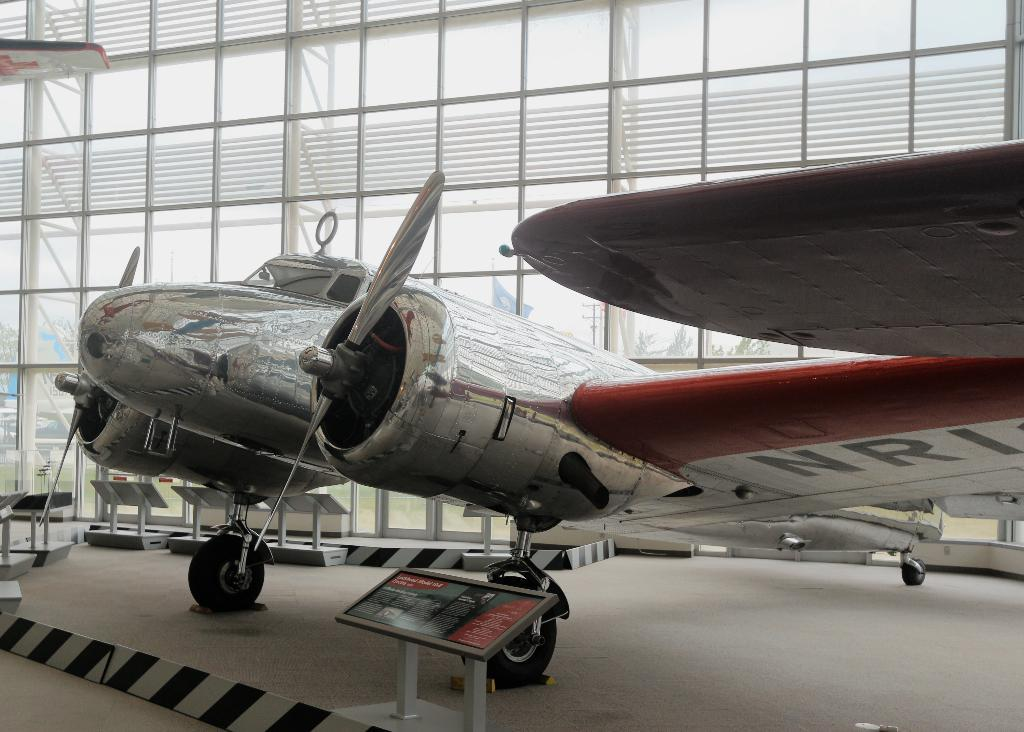<image>
Write a terse but informative summary of the picture. A chrome airplane is parked in a museum and says NRI under the wing. 